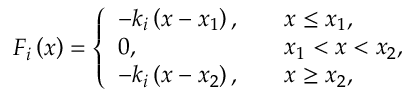Convert formula to latex. <formula><loc_0><loc_0><loc_500><loc_500>F _ { i } \left ( x \right ) = \left \{ \begin{array} { l l } { - k _ { i } \left ( x - x _ { 1 } \right ) , } & { \quad x \leq x _ { 1 } , } \\ { 0 , } & { \quad x _ { 1 } < x < x _ { 2 } , } \\ { - k _ { i } \left ( x - x _ { 2 } \right ) , } & { \quad x \geq x _ { 2 } , } \end{array}</formula> 